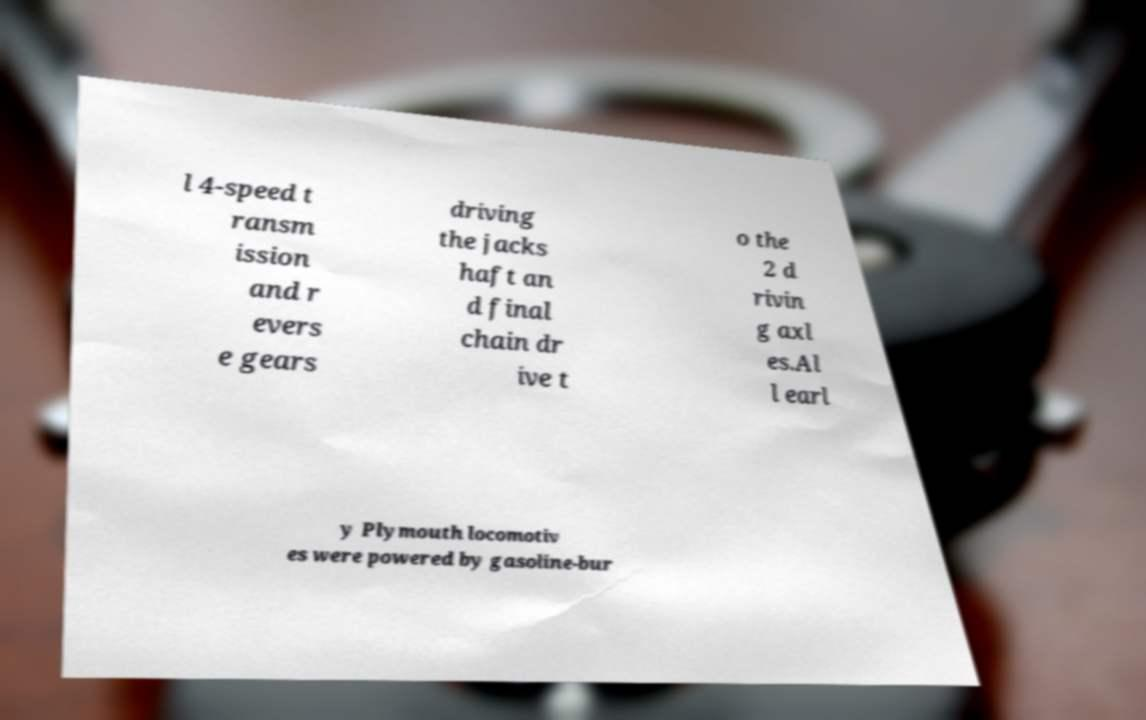There's text embedded in this image that I need extracted. Can you transcribe it verbatim? l 4-speed t ransm ission and r evers e gears driving the jacks haft an d final chain dr ive t o the 2 d rivin g axl es.Al l earl y Plymouth locomotiv es were powered by gasoline-bur 